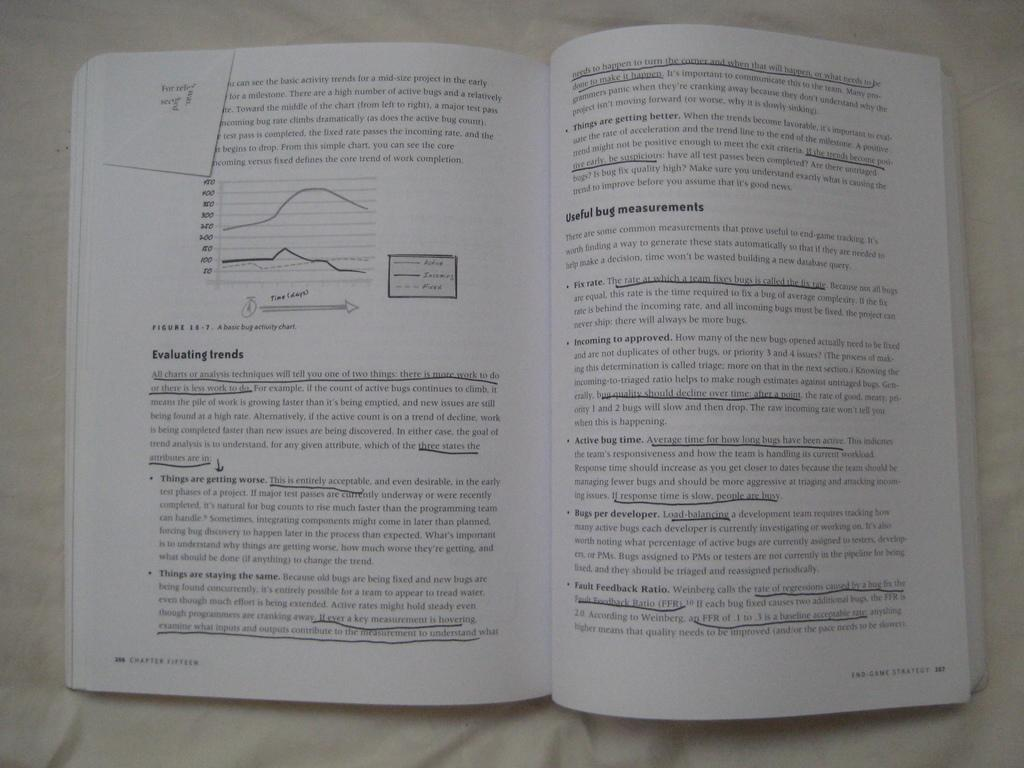Provide a one-sentence caption for the provided image. The Book 'End Game Strategy is opened to Chapter Fifteen with multiple sentences underlined on the pages. 